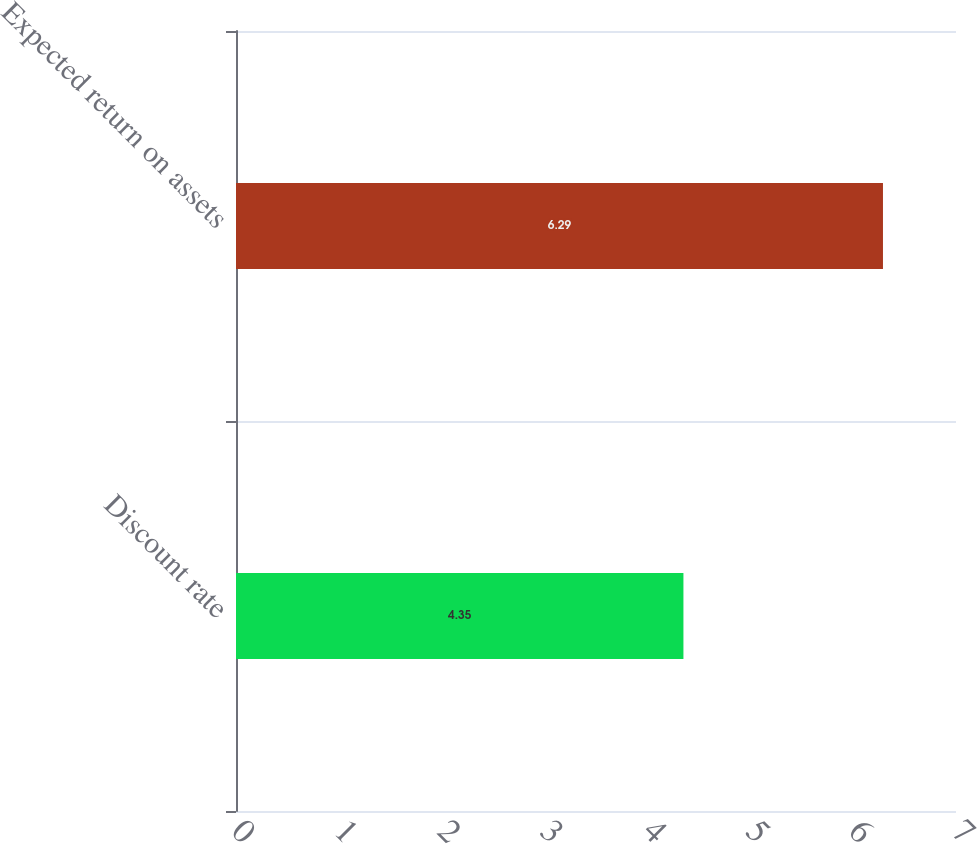Convert chart. <chart><loc_0><loc_0><loc_500><loc_500><bar_chart><fcel>Discount rate<fcel>Expected return on assets<nl><fcel>4.35<fcel>6.29<nl></chart> 